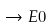Convert formula to latex. <formula><loc_0><loc_0><loc_500><loc_500>\rightarrow E 0</formula> 